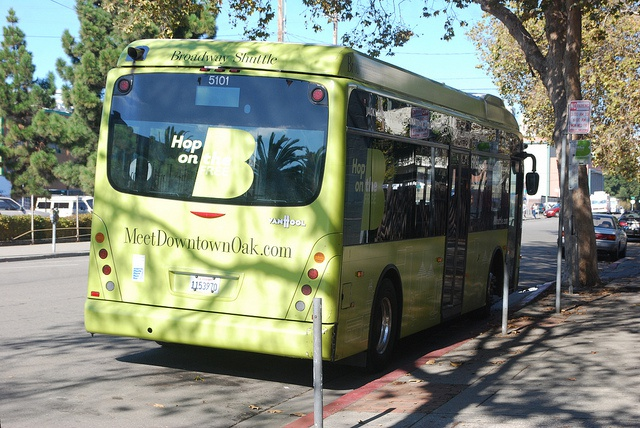Describe the objects in this image and their specific colors. I can see bus in lightblue, black, khaki, lightyellow, and gray tones, car in lightblue, black, gray, navy, and darkgray tones, car in lightblue, white, gray, darkgray, and black tones, car in lightblue, black, gray, darkgray, and lightgray tones, and car in lightblue, lightgray, darkgray, and gray tones in this image. 